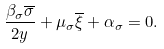<formula> <loc_0><loc_0><loc_500><loc_500>\frac { \beta _ { \sigma } \overline { \sigma } } { 2 y } + \mu _ { \sigma } \overline { \xi } + \alpha _ { \sigma } = 0 .</formula> 